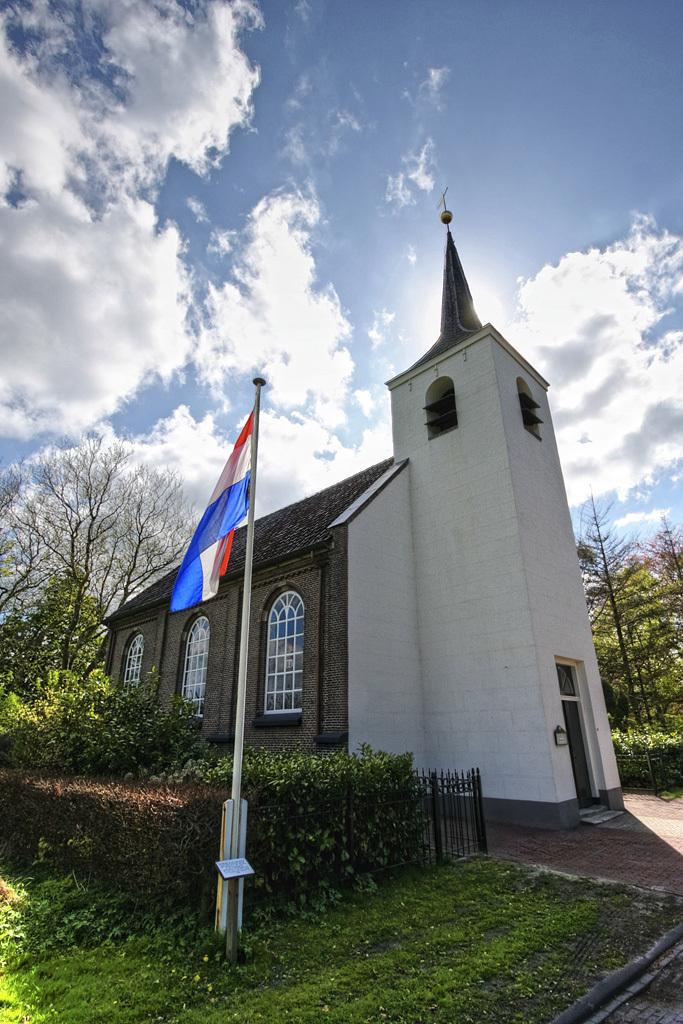What can be seen in the center of the image? There are two poles in the center of the image. What is attached to one of the poles? There is a flag on one of the poles. What can be seen on the ground in the image? There is paper visible in the image. What is visible in the background of the image? The sky, clouds, at least one building, grass, trees, and a fence are visible in the background. What features can be seen on the building in the background? Windows are visible on the building. Where is the oven located in the image? There is no oven present in the image. What type of judge is depicted in the image? There is no judge depicted in the image. 